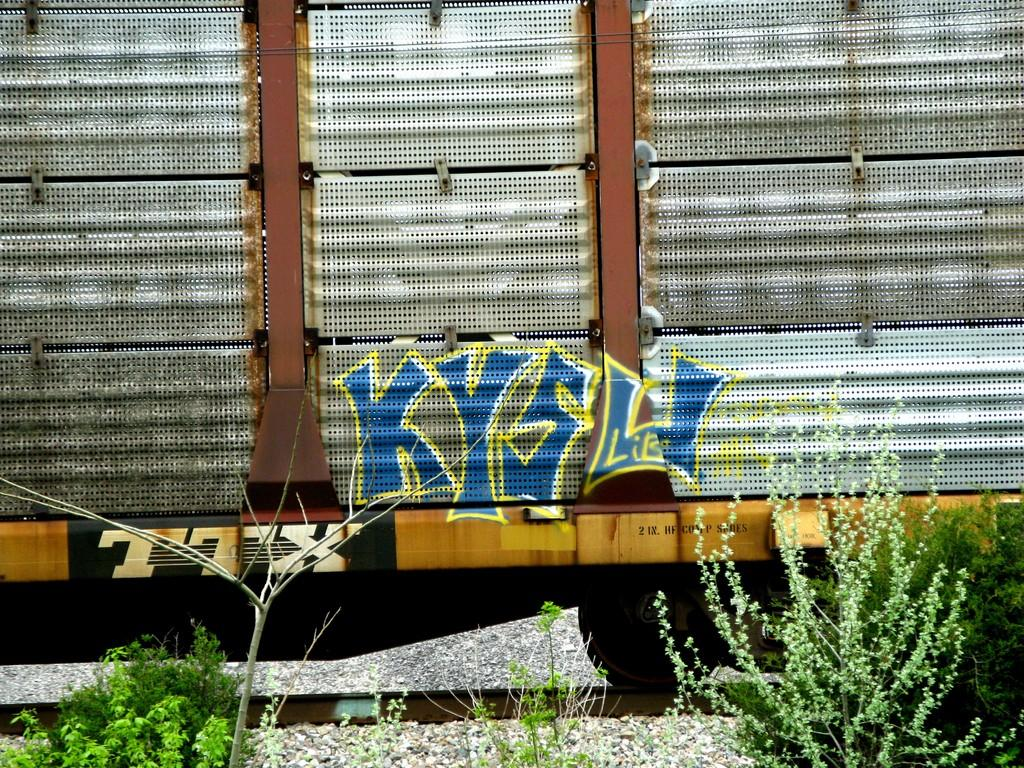What is the main subject in the middle of the image? There is a train wagon in the middle of the image. What can be seen at the bottom of the image? There are stones at the bottom of the image. Are there any plants visible in the image? Yes, small plants are present beside the train wagon. What is depicted on the train wagon? There is a painting on the train wagon. How many chickens are running through the snow in the image? There are no chickens or snow present in the image. What type of pain is the person experiencing in the image? There is no person experiencing pain in the image; it features a train wagon with a painting on it. 